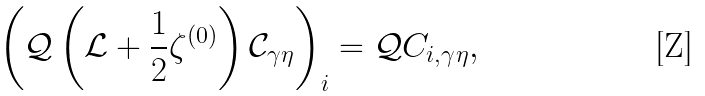Convert formula to latex. <formula><loc_0><loc_0><loc_500><loc_500>\left ( \mathcal { Q } \left ( \mathcal { L } + \frac { 1 } { 2 } \zeta ^ { ( 0 ) } \right ) \mathcal { C } _ { \gamma \eta } \right ) _ { i } = \mathcal { Q } C _ { i , \gamma \eta } ,</formula> 